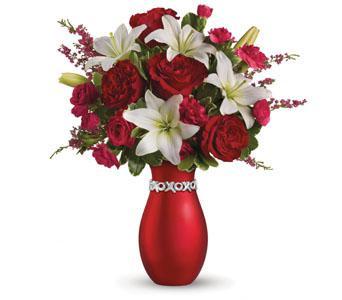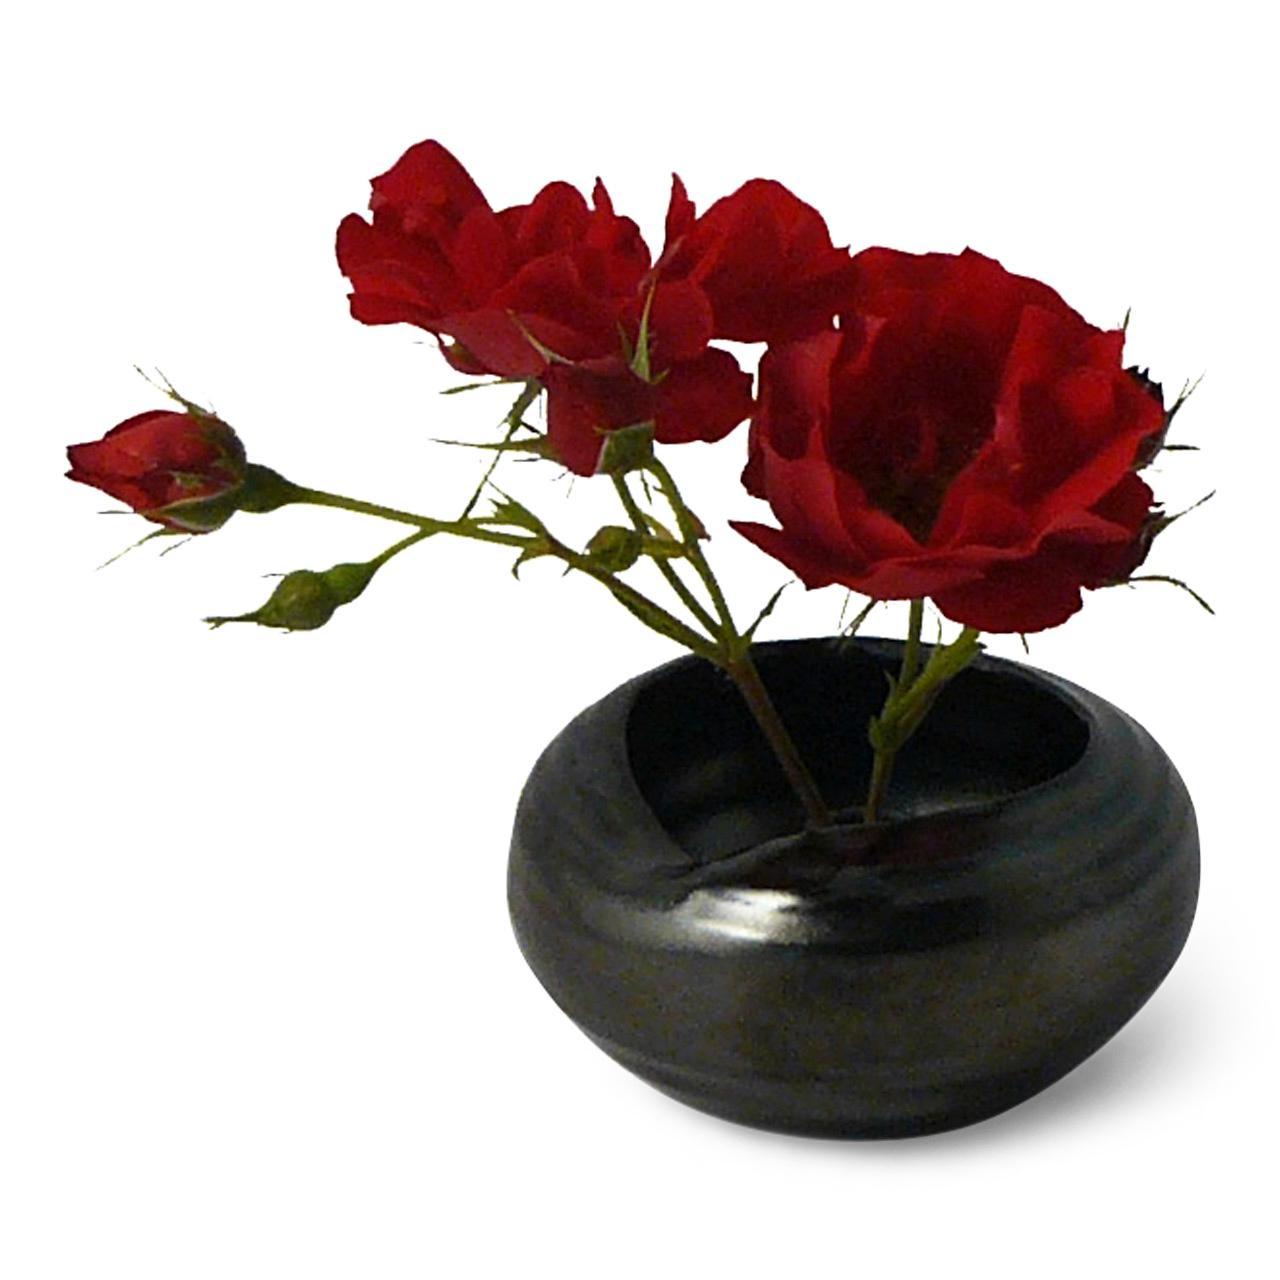The first image is the image on the left, the second image is the image on the right. Analyze the images presented: Is the assertion "A short black vase has red flowers." valid? Answer yes or no. Yes. The first image is the image on the left, the second image is the image on the right. Analyze the images presented: Is the assertion "The right image contains white flowers in a black vase." valid? Answer yes or no. No. 